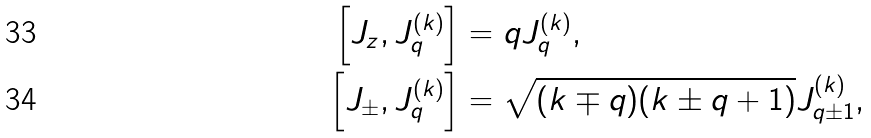<formula> <loc_0><loc_0><loc_500><loc_500>\left [ J _ { z } , J _ { q } ^ { ( k ) } \right ] & = q J _ { q } ^ { ( k ) } , \\ \left [ J _ { \pm } , J _ { q } ^ { ( k ) } \right ] & = \sqrt { ( k \mp q ) ( k \pm q + 1 ) } J _ { q \pm 1 } ^ { ( k ) } ,</formula> 